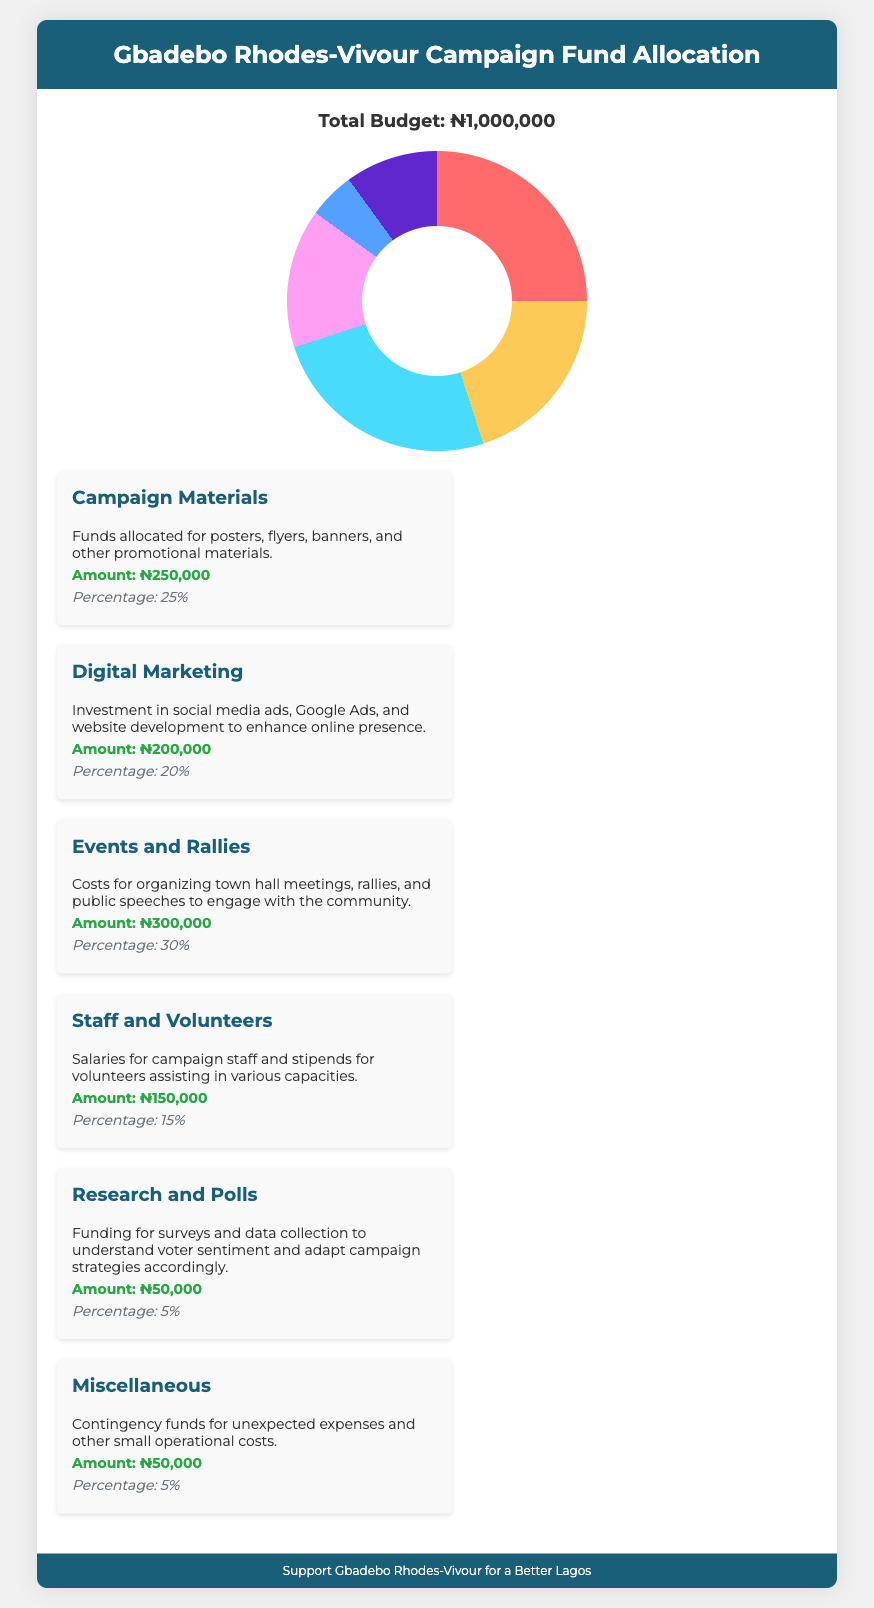What is the total budget? The total budget is stated prominently in the document as ₦1,000,000.
Answer: ₦1,000,000 How much is allocated for Campaign Materials? The section specifies that ₦250,000 is allocated for Campaign Materials.
Answer: ₦250,000 What percentage of the budget is dedicated to Events and Rallies? The document indicates that 30% of the total budget is allocated to Events and Rallies.
Answer: 30% How much funding is set aside for Research and Polls? Research and Polls receive an allocation of ₦50,000 as outlined in the document.
Answer: ₦50,000 What is the percentage allocated for Staff and Volunteers? The document specifies that 15% of the budget is allocated for Staff and Volunteers.
Answer: 15% Which category has the highest funding allocation? The highest funding allocation is for Events and Rallies, which receives ₦300,000.
Answer: Events and Rallies What are the total percentages accounted for in the budget? The total percentages in the budget add up to 100%, accounting for all expenditure categories.
Answer: 100% What is the amount allocated for Miscellaneous expenses? The Miscellaneous category has an allocation of ₦50,000 as indicated in the document.
Answer: ₦50,000 What type of expenses does Digital Marketing cover? Digital Marketing covers social media ads, Google Ads, and website development expenses.
Answer: Digital Marketing covers social media ads, Google Ads, and website development 